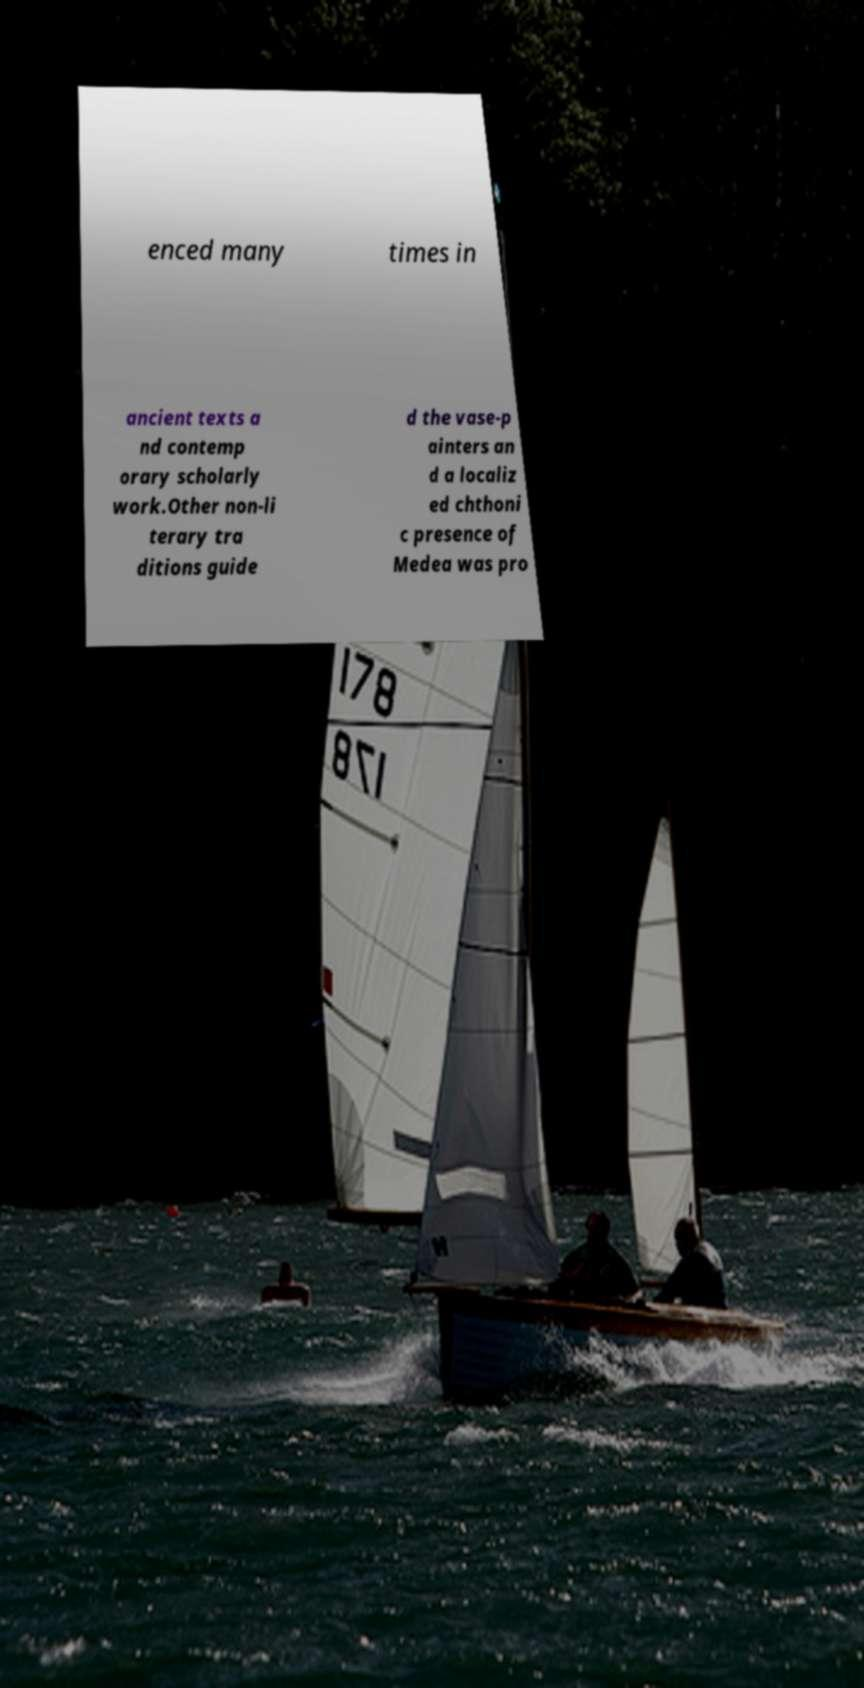Can you read and provide the text displayed in the image?This photo seems to have some interesting text. Can you extract and type it out for me? enced many times in ancient texts a nd contemp orary scholarly work.Other non-li terary tra ditions guide d the vase-p ainters an d a localiz ed chthoni c presence of Medea was pro 